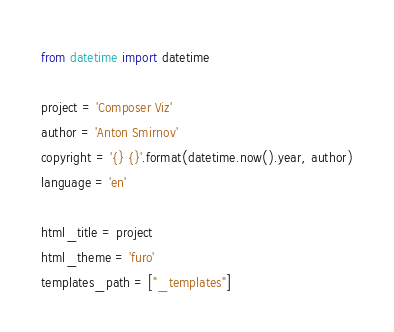<code> <loc_0><loc_0><loc_500><loc_500><_Python_>from datetime import datetime

project = 'Composer Viz'
author = 'Anton Smirnov'
copyright = '{} {}'.format(datetime.now().year, author)
language = 'en'

html_title = project
html_theme = 'furo'
templates_path = ["_templates"]
</code> 